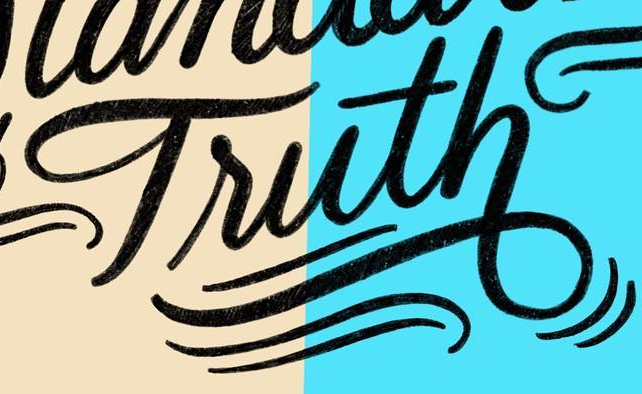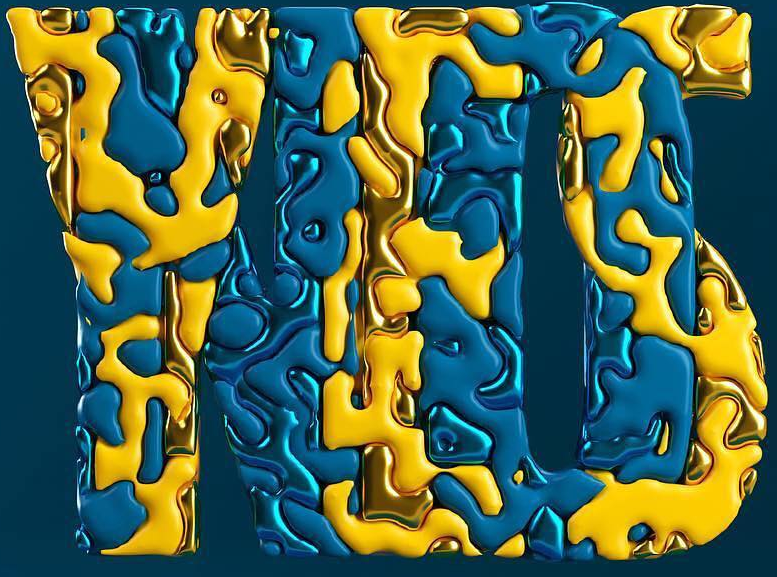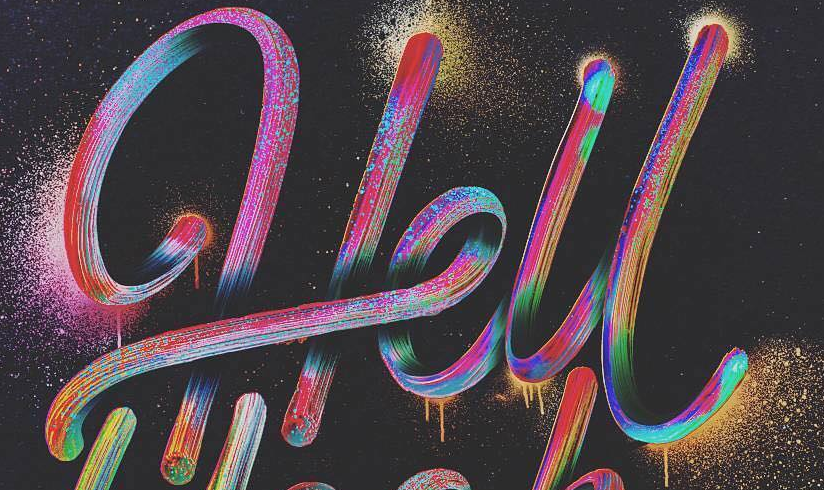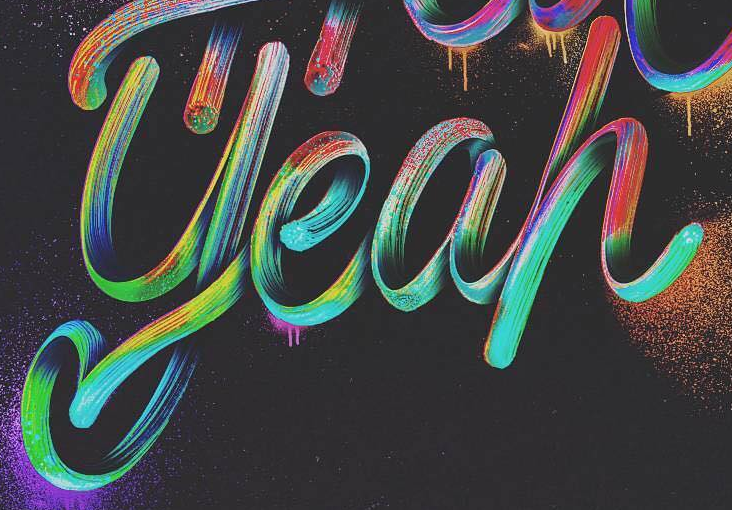What words can you see in these images in sequence, separated by a semicolon? Truth; YES; Hell; yeah 